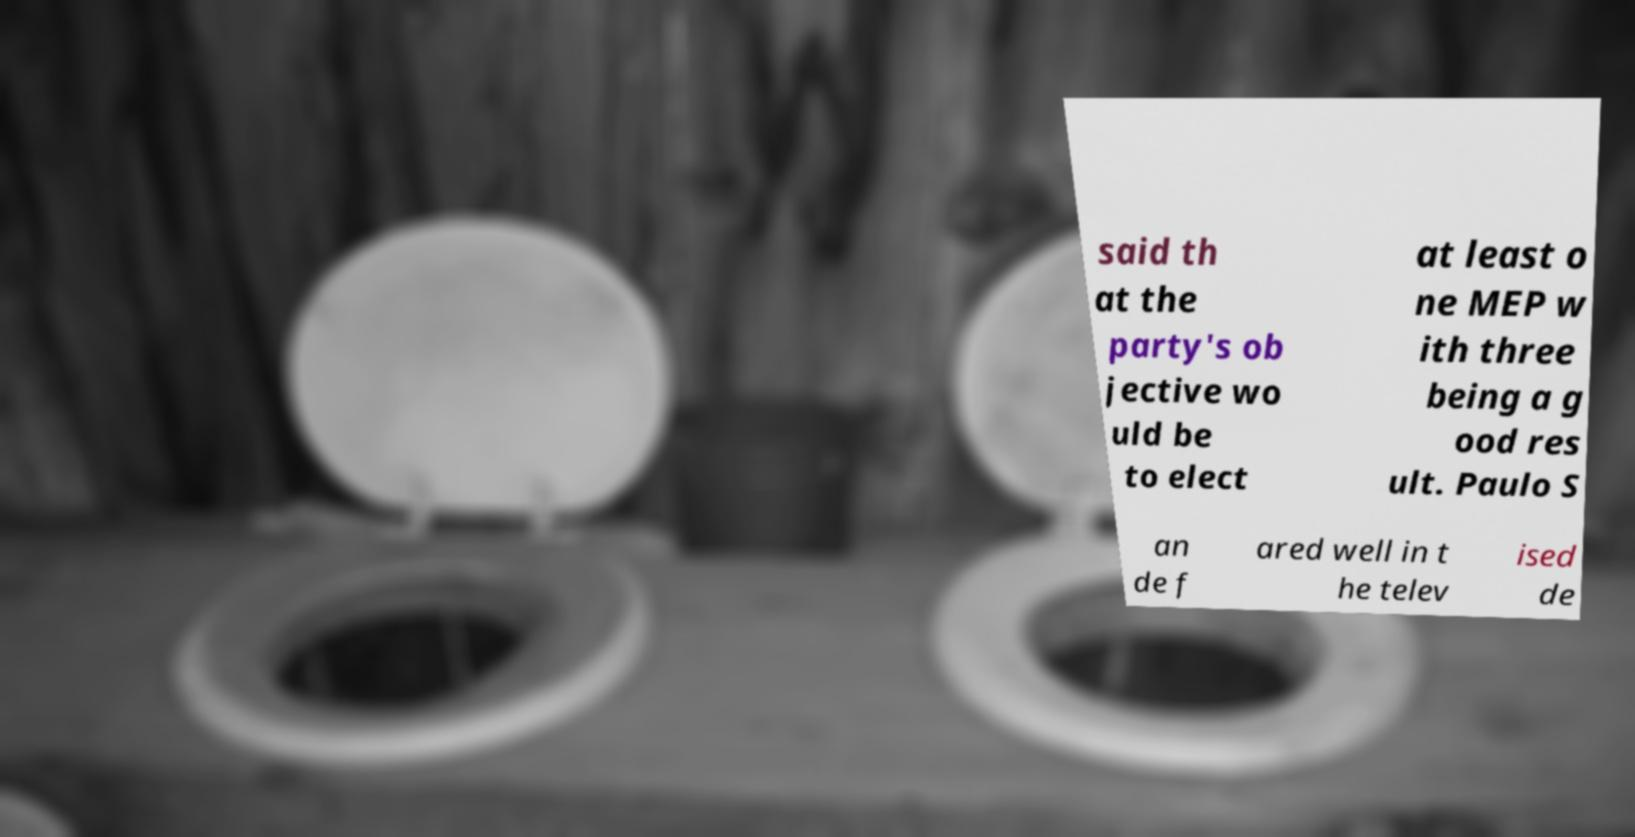Please identify and transcribe the text found in this image. said th at the party's ob jective wo uld be to elect at least o ne MEP w ith three being a g ood res ult. Paulo S an de f ared well in t he telev ised de 